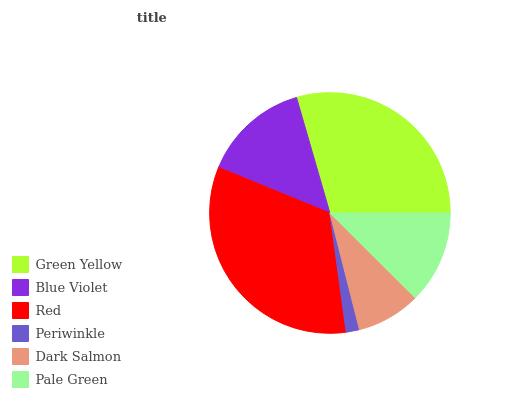Is Periwinkle the minimum?
Answer yes or no. Yes. Is Red the maximum?
Answer yes or no. Yes. Is Blue Violet the minimum?
Answer yes or no. No. Is Blue Violet the maximum?
Answer yes or no. No. Is Green Yellow greater than Blue Violet?
Answer yes or no. Yes. Is Blue Violet less than Green Yellow?
Answer yes or no. Yes. Is Blue Violet greater than Green Yellow?
Answer yes or no. No. Is Green Yellow less than Blue Violet?
Answer yes or no. No. Is Blue Violet the high median?
Answer yes or no. Yes. Is Pale Green the low median?
Answer yes or no. Yes. Is Pale Green the high median?
Answer yes or no. No. Is Dark Salmon the low median?
Answer yes or no. No. 